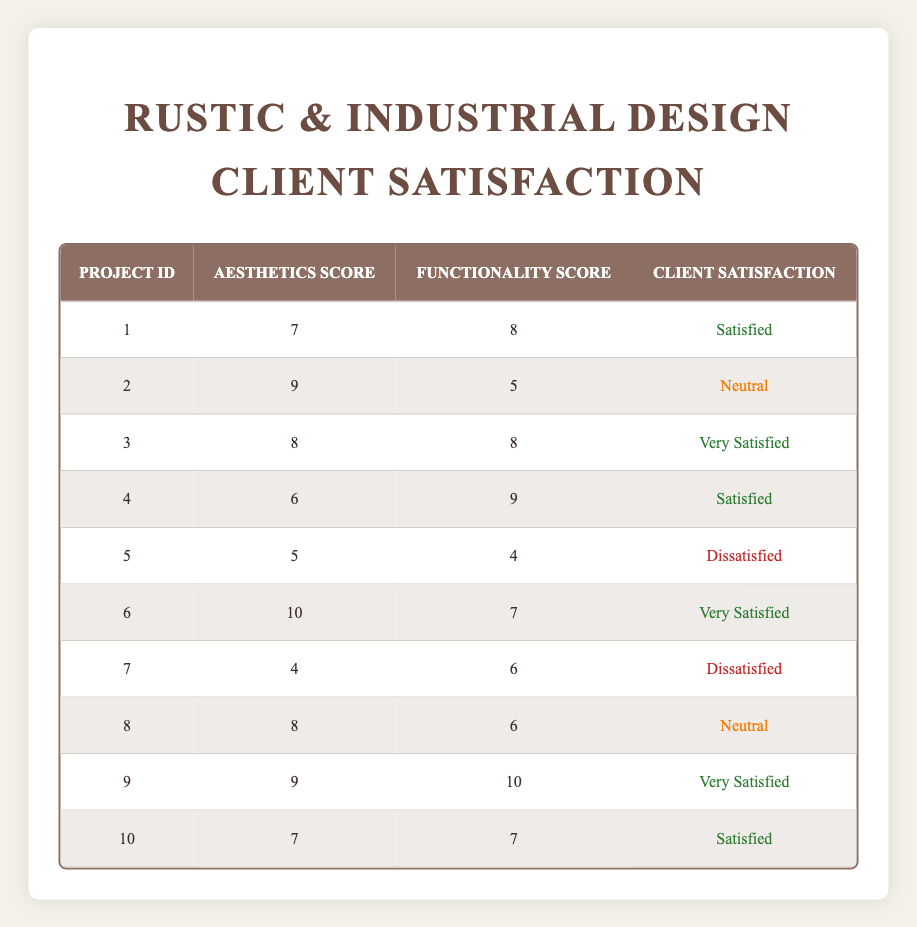What is the aesthetics score for project ID 6? Referring to the table, I locate project ID 6 and check the "Aesthetics Score" column. It shows a score of 10.
Answer: 10 How many projects received a client satisfaction rating of "Dissatisfied"? By scanning the "Client Satisfaction" column, I count the number of "Dissatisfied" ratings, which are present for projects ID 5 and 7. This gives a total of 2 projects.
Answer: 2 What is the average functionality score across all projects? To find the average functionality score, I sum the scores of all functionality ratings: (8 + 5 + 8 + 9 + 4 + 7 + 6 + 6 + 10 + 7) = 70. Then, divide by the number of projects (10): 70/10 = 7.
Answer: 7 Is there any project that scored an aesthetics score of 9 and received a "Neutral" rating? Looking at the table, project ID 2 has an aesthetics score of 9 and a "Neutral" rating, so the answer is yes.
Answer: Yes What is the difference between the highest and lowest aesthetics scores? The highest aesthetics score is 10 (project ID 6) and the lowest is 4 (project ID 7). The difference is calculated as 10 - 4 = 6.
Answer: 6 How many projects have both aesthetics and functionality scores greater than or equal to 8? First, I check each project's scores. Projects with both scores ≥ 8 are IDs 3 (8, 8), 6 (10, 7), and 9 (9, 10). That's 3 projects in total.
Answer: 3 Which project has the highest client satisfaction rating, and what is the corresponding score? Scanning the "Client Satisfaction" column, I find that project ID 9 has the highest rating of "Very Satisfied." The aesthetics and functionality scores for this project are 9 and 10 respectively.
Answer: Project ID 9, scores 9 and 10 How many projects rated "Very Satisfied" have aesthetics scores above 8? I identify the projects rated "Very Satisfied" which are ID 3 (aesthetics 8) and ID 6 (aesthetics 10). Only ID 6 has an aesthetics score above 8, resulting in 1 project.
Answer: 1 Which aesthetic score is most common among the projects? I count the occurrences of each aesthetics score: 4 (1x), 5 (1x), 6 (1x), 7 (3x), 8 (3x), 9 (2x), and 10 (1x). The most common scores are 7 and 8, occurring 3 times each.
Answer: 7 and 8 